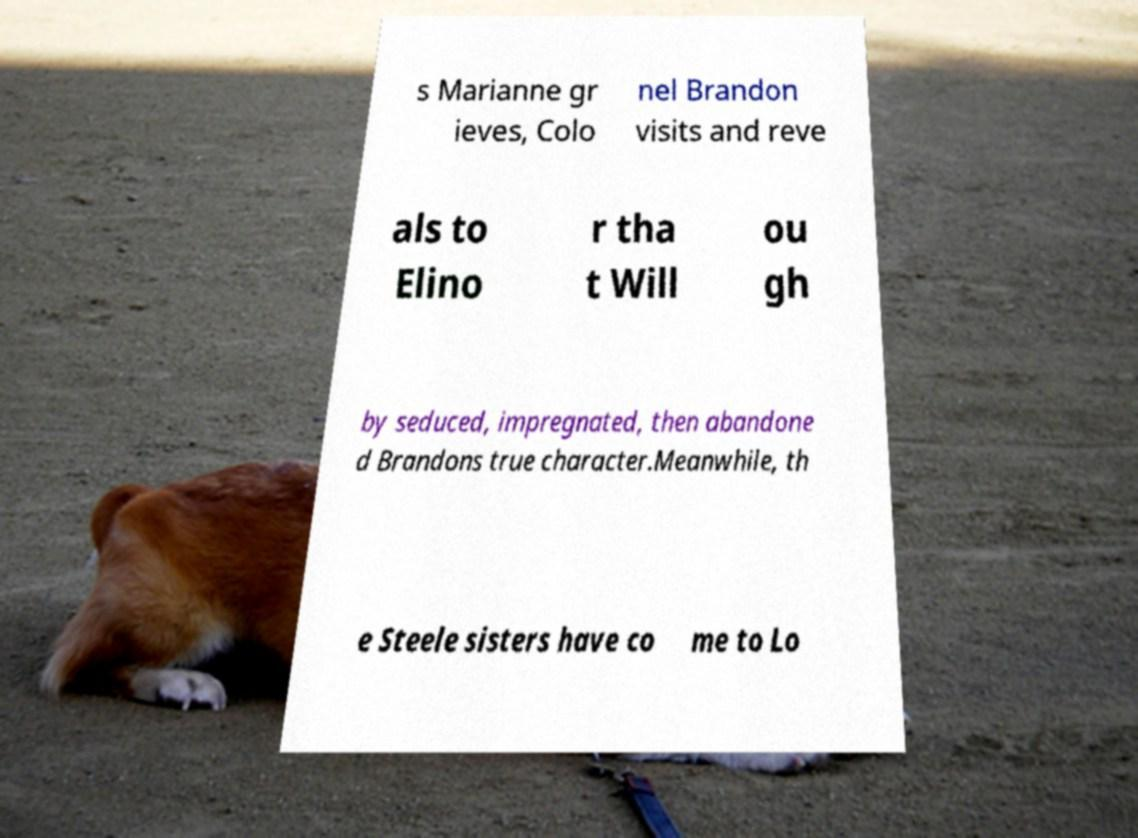There's text embedded in this image that I need extracted. Can you transcribe it verbatim? s Marianne gr ieves, Colo nel Brandon visits and reve als to Elino r tha t Will ou gh by seduced, impregnated, then abandone d Brandons true character.Meanwhile, th e Steele sisters have co me to Lo 